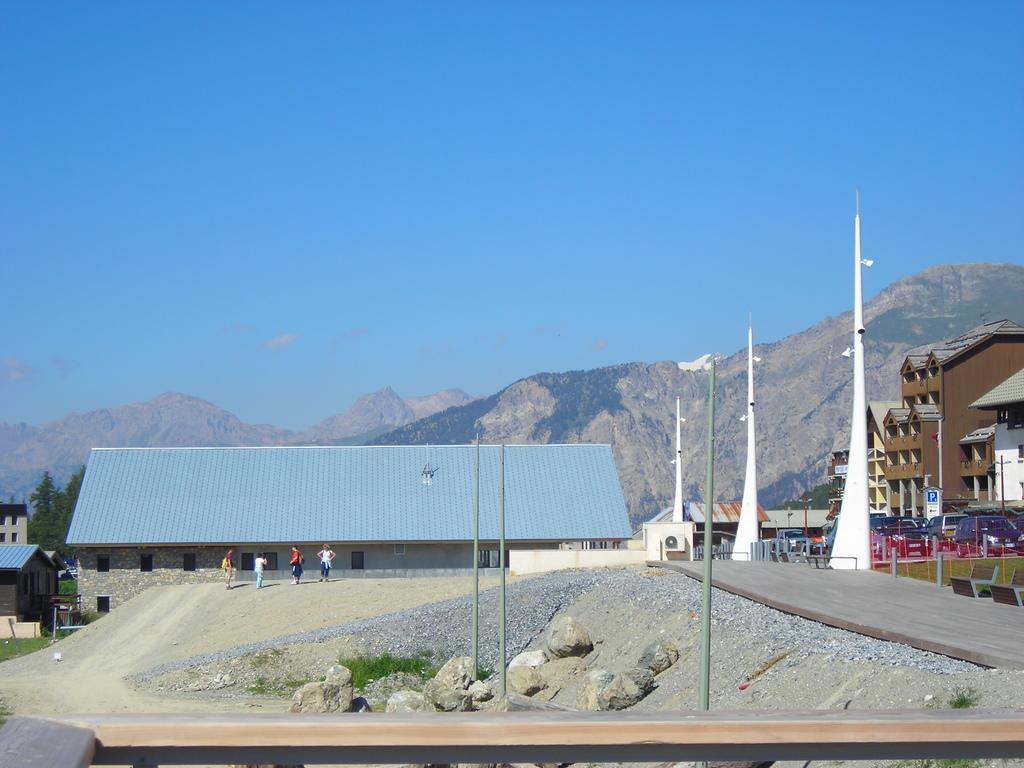Describe this image in one or two sentences. In this image I can see the hill, the sky , buildings and there are few persons ,road, poles, vehicles, some trees,some stones visible in the middle. 